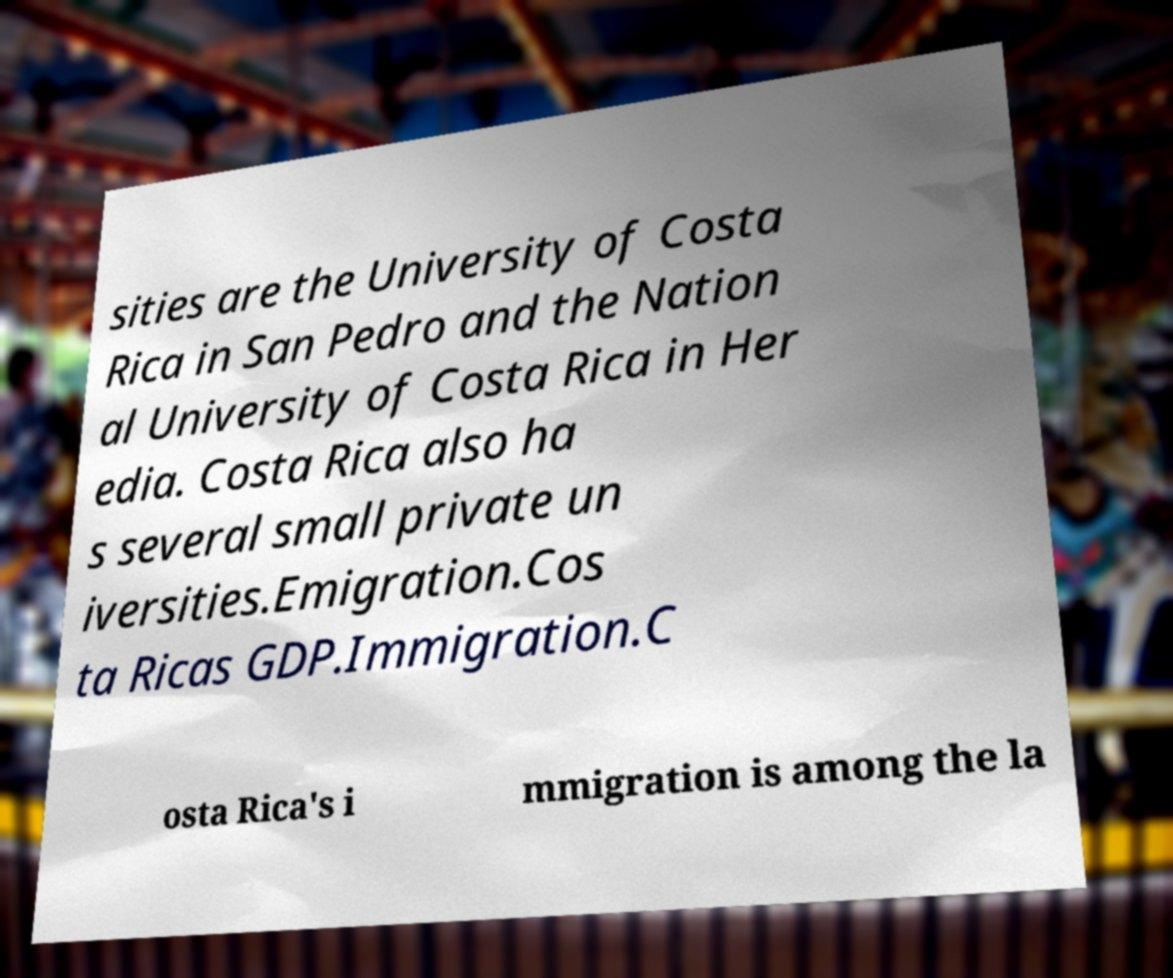There's text embedded in this image that I need extracted. Can you transcribe it verbatim? sities are the University of Costa Rica in San Pedro and the Nation al University of Costa Rica in Her edia. Costa Rica also ha s several small private un iversities.Emigration.Cos ta Ricas GDP.Immigration.C osta Rica's i mmigration is among the la 